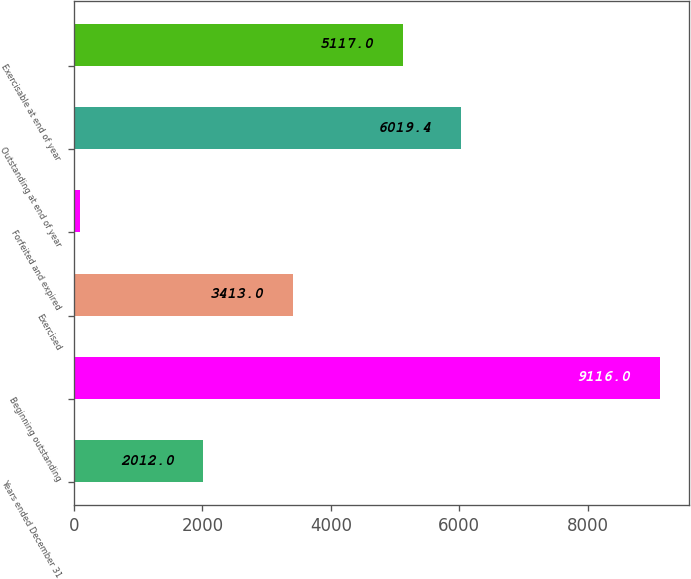<chart> <loc_0><loc_0><loc_500><loc_500><bar_chart><fcel>Years ended December 31<fcel>Beginning outstanding<fcel>Exercised<fcel>Forfeited and expired<fcel>Outstanding at end of year<fcel>Exercisable at end of year<nl><fcel>2012<fcel>9116<fcel>3413<fcel>92<fcel>6019.4<fcel>5117<nl></chart> 